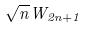<formula> <loc_0><loc_0><loc_500><loc_500>\sqrt { n } W _ { 2 n + 1 }</formula> 